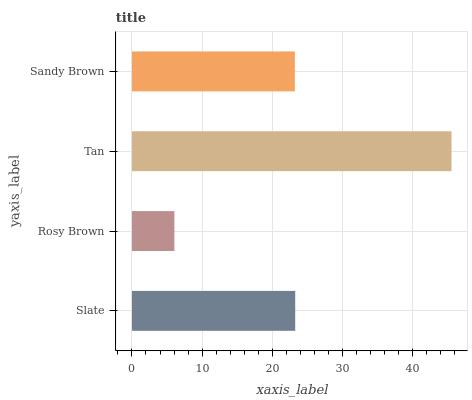Is Rosy Brown the minimum?
Answer yes or no. Yes. Is Tan the maximum?
Answer yes or no. Yes. Is Tan the minimum?
Answer yes or no. No. Is Rosy Brown the maximum?
Answer yes or no. No. Is Tan greater than Rosy Brown?
Answer yes or no. Yes. Is Rosy Brown less than Tan?
Answer yes or no. Yes. Is Rosy Brown greater than Tan?
Answer yes or no. No. Is Tan less than Rosy Brown?
Answer yes or no. No. Is Slate the high median?
Answer yes or no. Yes. Is Sandy Brown the low median?
Answer yes or no. Yes. Is Sandy Brown the high median?
Answer yes or no. No. Is Slate the low median?
Answer yes or no. No. 